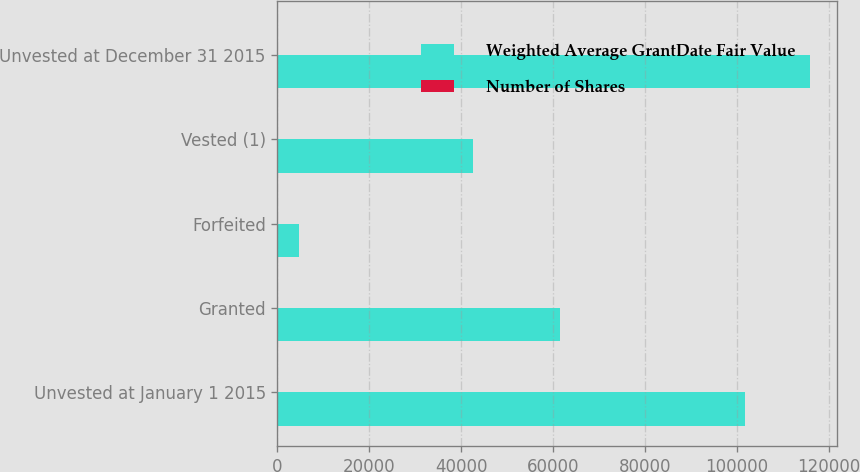<chart> <loc_0><loc_0><loc_500><loc_500><stacked_bar_chart><ecel><fcel>Unvested at January 1 2015<fcel>Granted<fcel>Forfeited<fcel>Vested (1)<fcel>Unvested at December 31 2015<nl><fcel>Weighted Average GrantDate Fair Value<fcel>101723<fcel>61611<fcel>4690<fcel>42584<fcel>116060<nl><fcel>Number of Shares<fcel>77.33<fcel>73.28<fcel>75.49<fcel>70.92<fcel>77.61<nl></chart> 